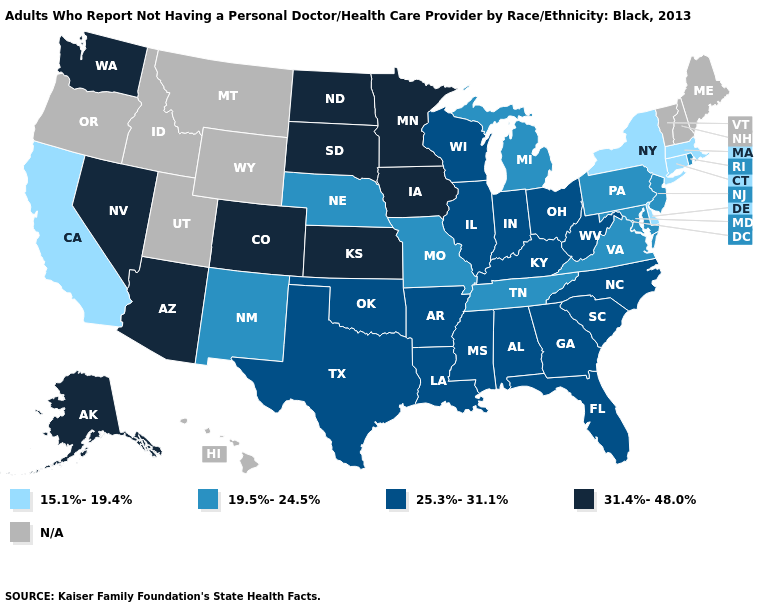Name the states that have a value in the range 25.3%-31.1%?
Give a very brief answer. Alabama, Arkansas, Florida, Georgia, Illinois, Indiana, Kentucky, Louisiana, Mississippi, North Carolina, Ohio, Oklahoma, South Carolina, Texas, West Virginia, Wisconsin. Which states have the highest value in the USA?
Write a very short answer. Alaska, Arizona, Colorado, Iowa, Kansas, Minnesota, Nevada, North Dakota, South Dakota, Washington. Name the states that have a value in the range 31.4%-48.0%?
Write a very short answer. Alaska, Arizona, Colorado, Iowa, Kansas, Minnesota, Nevada, North Dakota, South Dakota, Washington. Which states have the highest value in the USA?
Short answer required. Alaska, Arizona, Colorado, Iowa, Kansas, Minnesota, Nevada, North Dakota, South Dakota, Washington. Name the states that have a value in the range 31.4%-48.0%?
Give a very brief answer. Alaska, Arizona, Colorado, Iowa, Kansas, Minnesota, Nevada, North Dakota, South Dakota, Washington. Which states have the lowest value in the USA?
Write a very short answer. California, Connecticut, Delaware, Massachusetts, New York. Name the states that have a value in the range 15.1%-19.4%?
Short answer required. California, Connecticut, Delaware, Massachusetts, New York. What is the value of New Mexico?
Write a very short answer. 19.5%-24.5%. How many symbols are there in the legend?
Be succinct. 5. Which states have the lowest value in the Northeast?
Short answer required. Connecticut, Massachusetts, New York. Does the map have missing data?
Write a very short answer. Yes. What is the value of Nebraska?
Keep it brief. 19.5%-24.5%. How many symbols are there in the legend?
Keep it brief. 5. Among the states that border New Hampshire , which have the highest value?
Short answer required. Massachusetts. Name the states that have a value in the range 19.5%-24.5%?
Concise answer only. Maryland, Michigan, Missouri, Nebraska, New Jersey, New Mexico, Pennsylvania, Rhode Island, Tennessee, Virginia. 